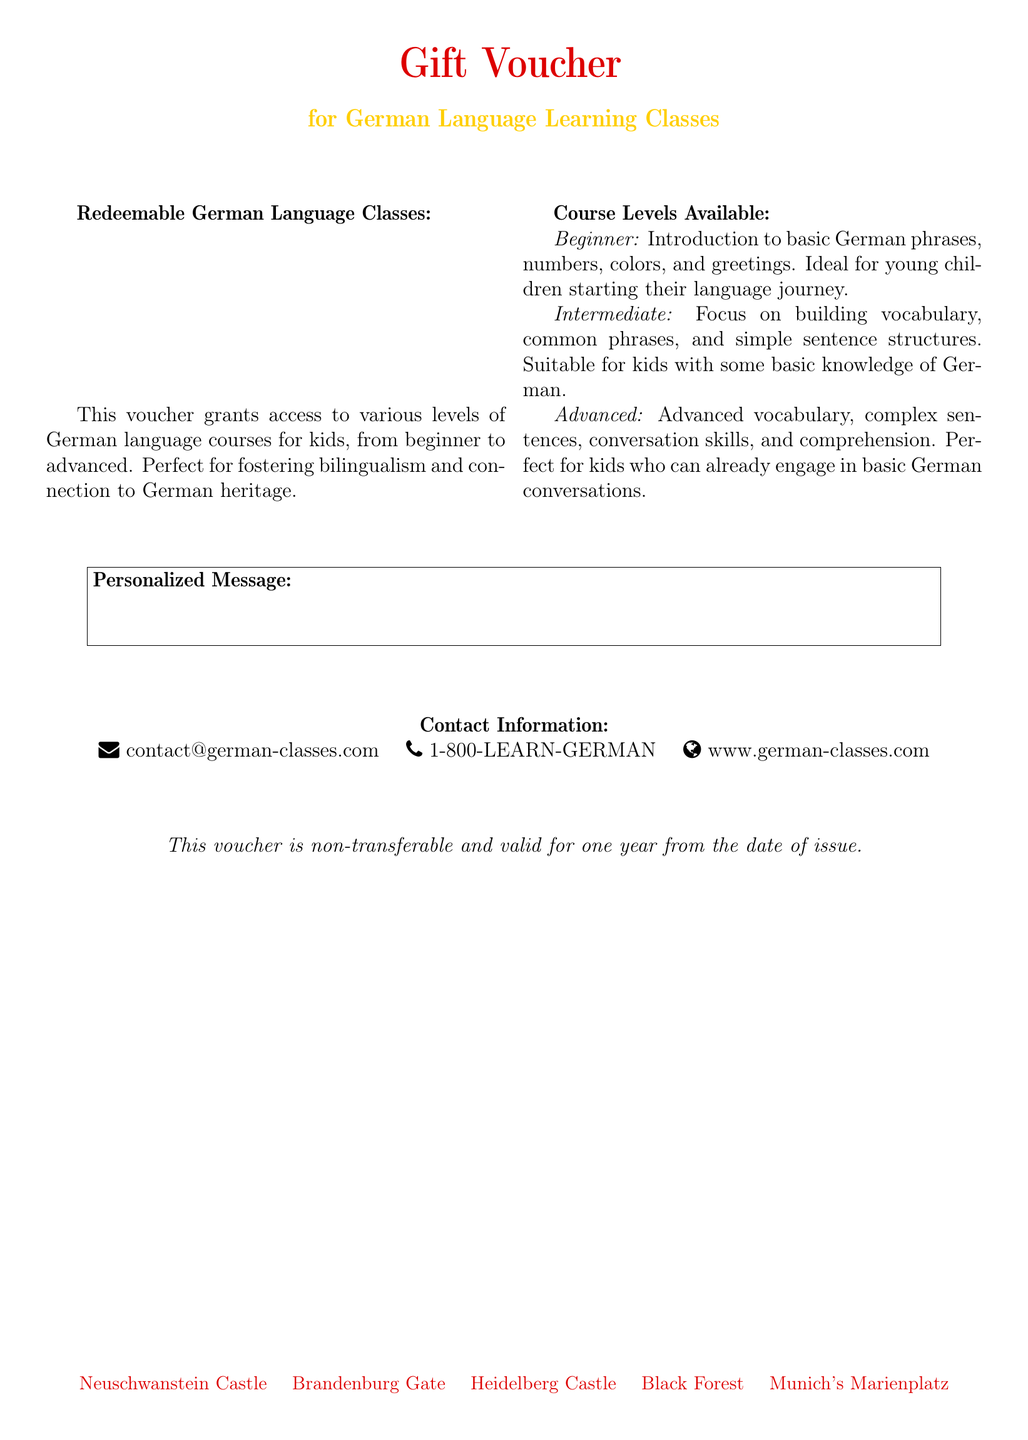What does the voucher grant access to? The voucher grants access to various levels of German language courses for kids.
Answer: German language courses What is the ideal age range for the beginner course? The beginner course is ideal for young children starting their language journey.
Answer: Young children What types of phrases are introduced in the beginner level? The beginner level introduces basic German phrases, numbers, colors, and greetings.
Answer: Basic phrases How long is the voucher valid for? The voucher is valid for one year from the date of issue.
Answer: One year What is the contact email provided in the voucher? The contact email for inquiries about the classes is listed under contact information.
Answer: contact@german-classes.com Which cultural landmarks are mentioned at the bottom of the document? The document lists several cultural landmarks related to Germany.
Answer: Neuschwanstein Castle, Brandenburg Gate, Heidelberg Castle, Black Forest, Munich's Marienplatz What is the advanced level focused on? The advanced level focuses on advanced vocabulary, complex sentences, conversation skills, and comprehension.
Answer: Advanced vocabulary Is the voucher transferable? The document states specific conditions regarding the voucher's usage.
Answer: Non-transferable 